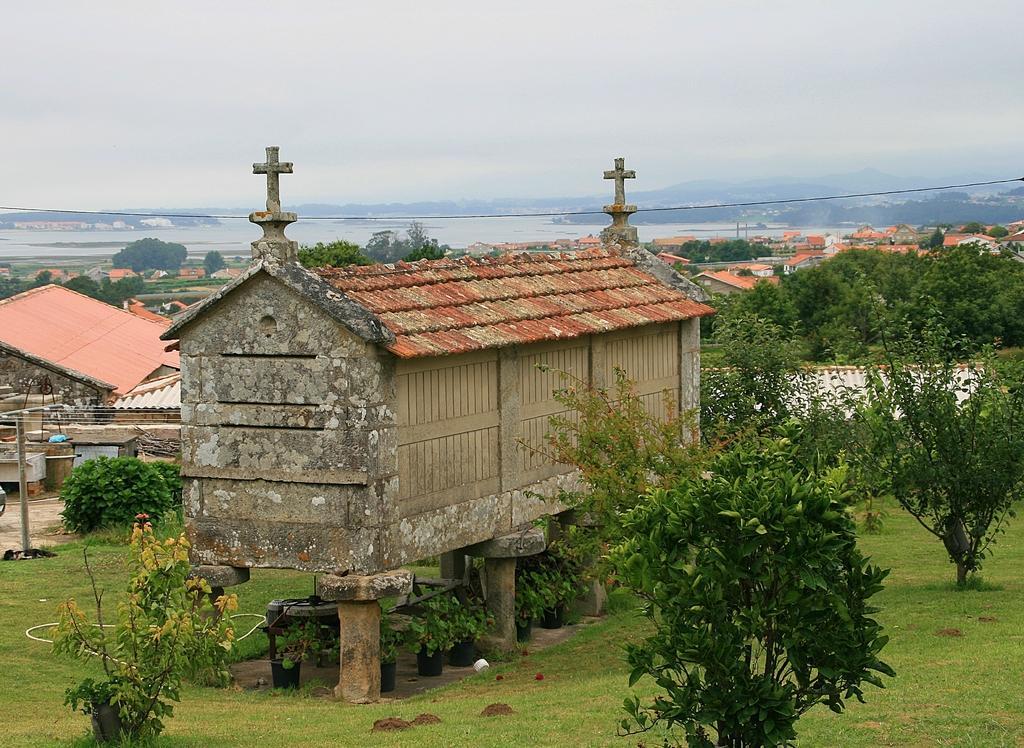Please provide a concise description of this image. In this picture we can see grass at the bottom, we can see trees and houses in the middle, in the background there is water, we can see the sky at the top of the picture. 